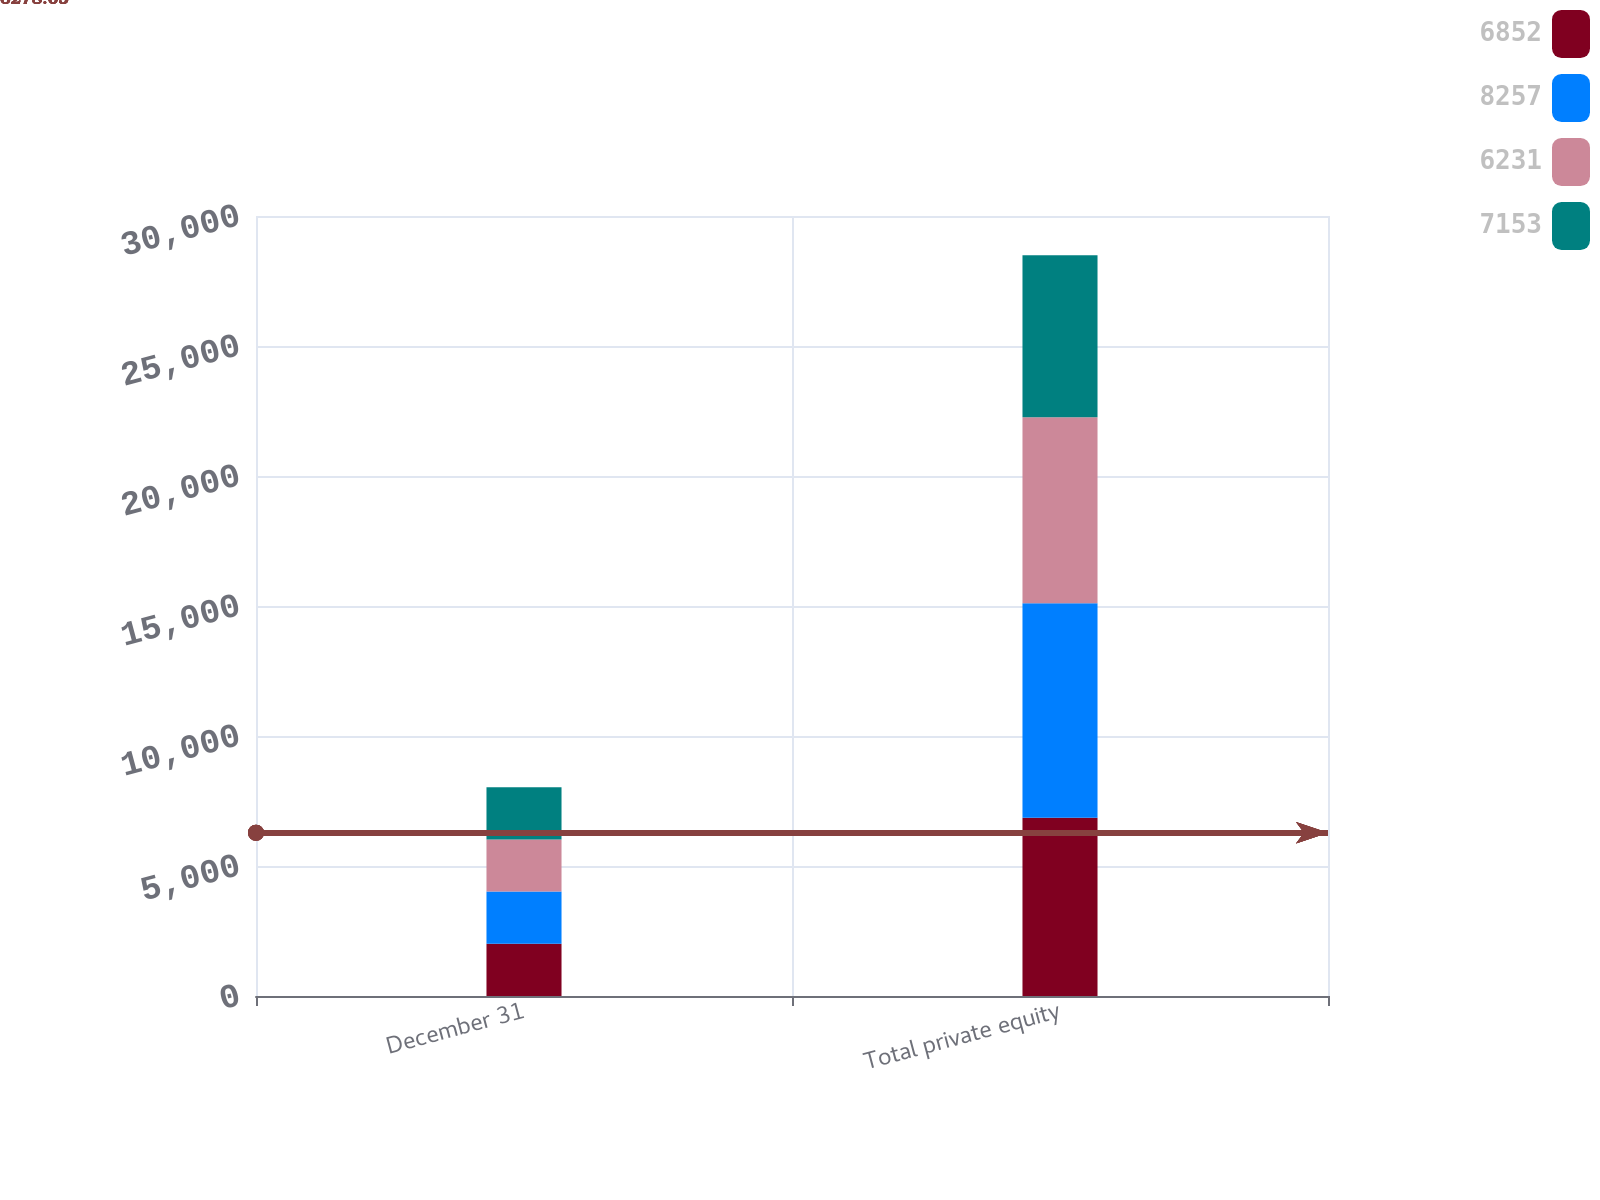Convert chart. <chart><loc_0><loc_0><loc_500><loc_500><stacked_bar_chart><ecel><fcel>December 31<fcel>Total private equity<nl><fcel>6852<fcel>2008<fcel>6852<nl><fcel>8257<fcel>2008<fcel>8257<nl><fcel>6231<fcel>2007<fcel>7153<nl><fcel>7153<fcel>2007<fcel>6231<nl></chart> 